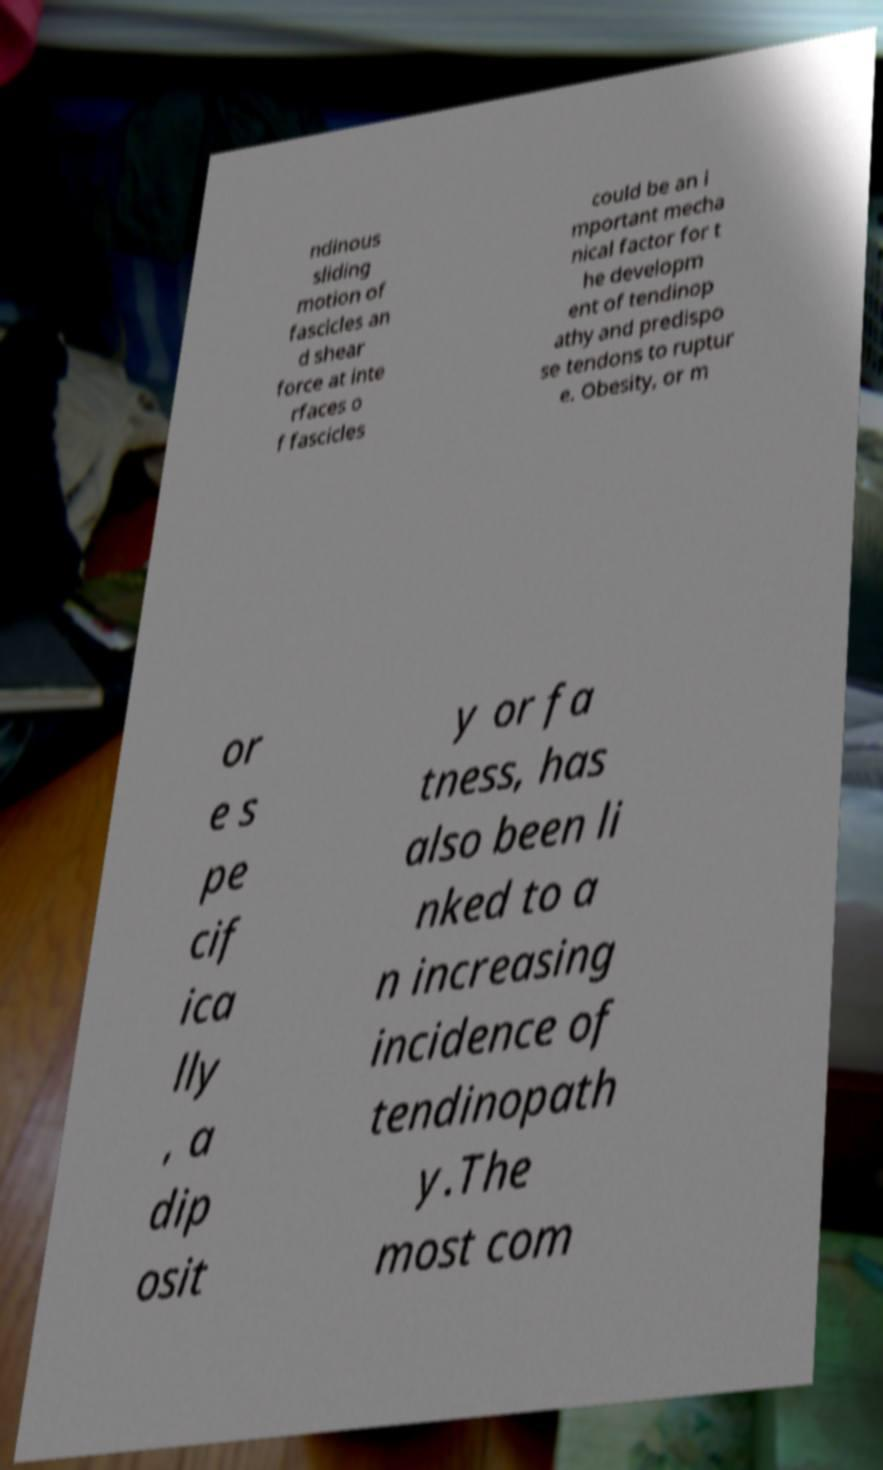Could you extract and type out the text from this image? ndinous sliding motion of fascicles an d shear force at inte rfaces o f fascicles could be an i mportant mecha nical factor for t he developm ent of tendinop athy and predispo se tendons to ruptur e. Obesity, or m or e s pe cif ica lly , a dip osit y or fa tness, has also been li nked to a n increasing incidence of tendinopath y.The most com 